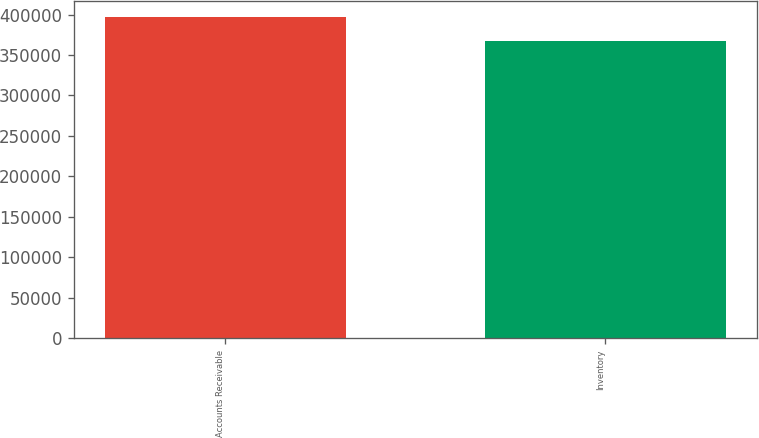Convert chart. <chart><loc_0><loc_0><loc_500><loc_500><bar_chart><fcel>Accounts Receivable<fcel>Inventory<nl><fcel>396605<fcel>367927<nl></chart> 